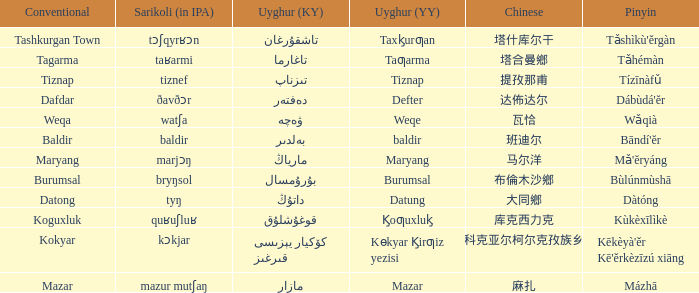Parse the table in full. {'header': ['Conventional', 'Sarikoli (in IPA)', 'Uyghur (KY)', 'Uyghur (YY)', 'Chinese', 'Pinyin'], 'rows': [['Tashkurgan Town', 'tɔʃqyrʁɔn', 'تاشقۇرغان', 'Taxk̡urƣan', '塔什库尔干', "Tǎshìkù'ěrgàn"], ['Tagarma', 'taʁarmi', 'تاغارما', 'Taƣarma', '塔合曼鄉', 'Tǎhémàn'], ['Tiznap', 'tiznef', 'تىزناپ', 'Tiznap', '提孜那甫', 'Tízīnàfǔ'], ['Dafdar', 'ðavðɔr', 'دەفتەر', 'Defter', '达佈达尔', "Dábùdá'ĕr"], ['Weqa', 'watʃa', 'ۋەچە', 'Weqe', '瓦恰', 'Wǎqià'], ['Baldir', 'baldir', 'بەلدىر', 'baldir', '班迪尔', "Bāndí'ĕr"], ['Maryang', 'marjɔŋ', 'مارياڭ', 'Maryang', '马尔洋', "Mǎ'ĕryáng"], ['Burumsal', 'bryŋsol', 'بۇرۇمسال', 'Burumsal', '布倫木沙鄉', 'Bùlúnmùshā'], ['Datong', 'tyŋ', 'داتۇڭ', 'Datung', '大同鄉', 'Dàtóng'], ['Koguxluk', 'quʁuʃluʁ', 'قوغۇشلۇق', 'K̡oƣuxluk̡', '库克西力克', 'Kùkèxīlìkè'], ['Kokyar', 'kɔkjar', 'كۆكيار قىرغىز يېزىسى', 'Kɵkyar K̡irƣiz yezisi', '科克亚尔柯尔克孜族乡', "Kēkèyà'ěr Kē'ěrkèzīzú xiāng"], ['Mazar', 'mazur mutʃaŋ', 'مازار', 'Mazar', '麻扎', 'Mázhā']]} Name the uyghur for  瓦恰 ۋەچە. 